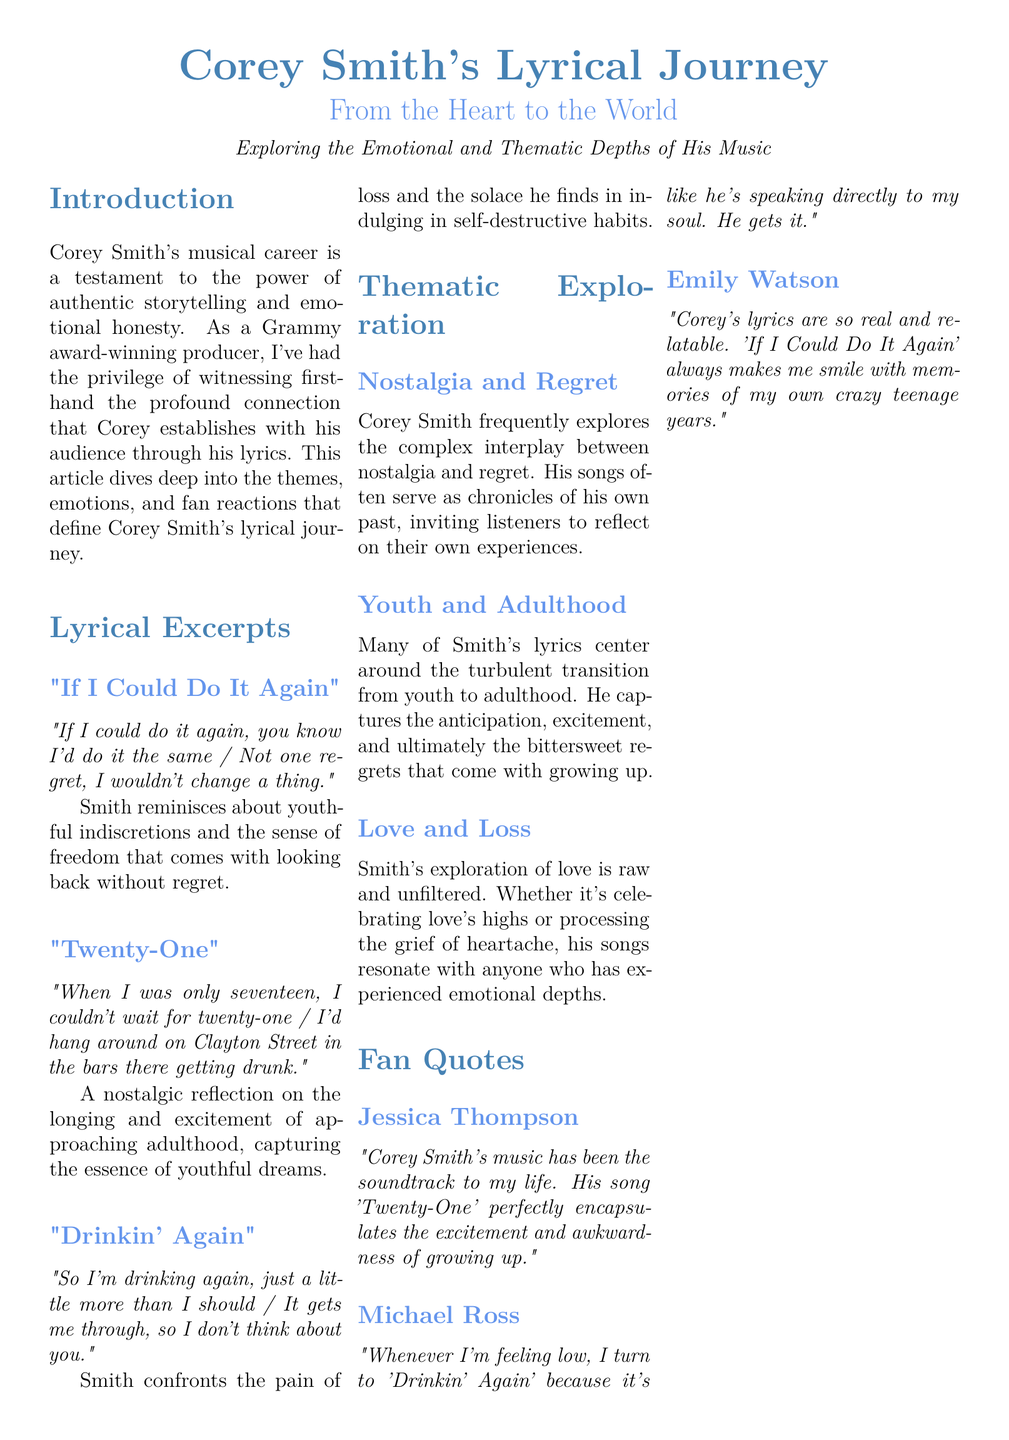What is the title of the article? The title of the article is presented prominently at the top of the document, highlighting Corey Smith's artistic journey.
Answer: Corey Smith's Lyrical Journey Who is the author of the quotes in the "Fan Quotes" section? The "Fan Quotes" section features various fans reflecting on Corey Smith's music, and their quotes are attributed to individuals rather than a single author.
Answer: Jessica Thompson, Michael Ross, Emily Watson Which song includes the lyric "If I could do it again, you know I'd do it the same"? This lyric belongs to one of the lyrical excerpts discussed in the document, providing insight into the theme of nostalgia.
Answer: If I Could Do It Again What is a key theme explored in Corey Smith's lyrics? The document outlines significant themes related to his music, highlighting the emotional journey conveyed through his work.
Answer: Nostalgia and Regret What emotional experience does the song "Drinkin' Again" address? The song addresses the feelings associated with loss and the coping mechanisms one might resort to, as highlighted in the article.
Answer: Pain of loss How does Jessica Thompson describe Corey Smith's music? Jessica Thompson's quote illustrates her connection to Smith's work, affirming the impact of his music on her personal experiences.
Answer: The soundtrack to my life What genre does Corey Smith's music fall under? While not explicitly stated in the document, Corey Smith is recognized for his contribution to a specific genre of music that blends emotional storytelling.
Answer: Country/folk music 